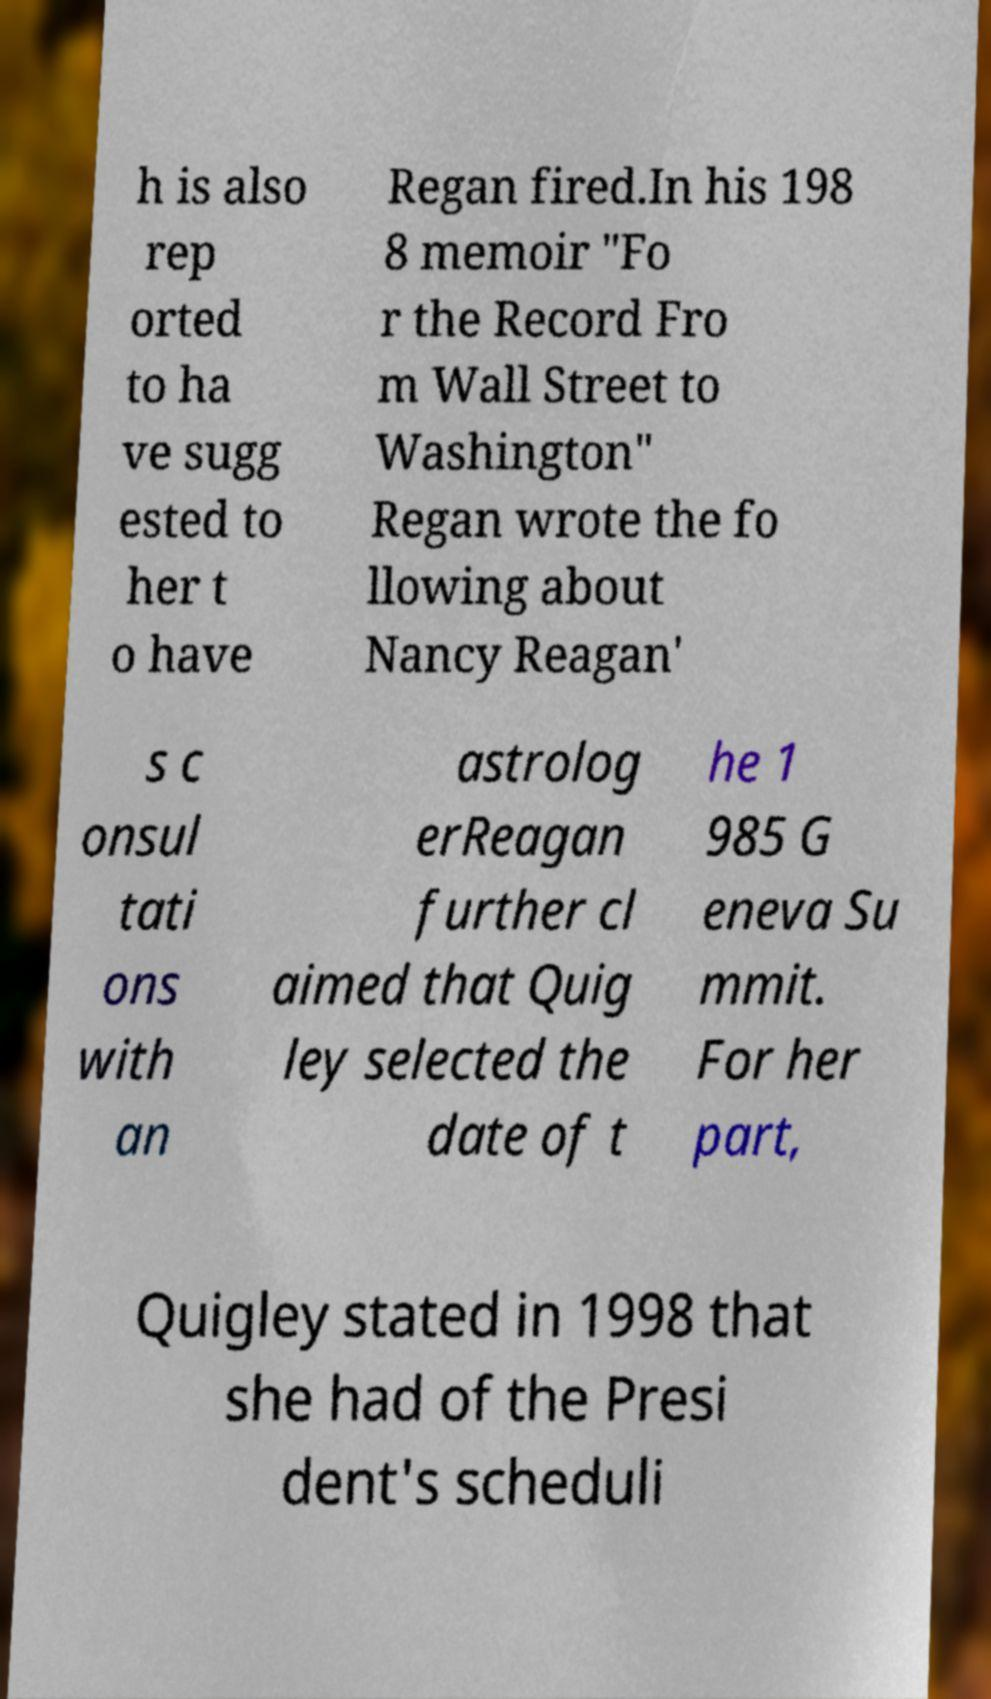Can you accurately transcribe the text from the provided image for me? h is also rep orted to ha ve sugg ested to her t o have Regan fired.In his 198 8 memoir "Fo r the Record Fro m Wall Street to Washington" Regan wrote the fo llowing about Nancy Reagan' s c onsul tati ons with an astrolog erReagan further cl aimed that Quig ley selected the date of t he 1 985 G eneva Su mmit. For her part, Quigley stated in 1998 that she had of the Presi dent's scheduli 